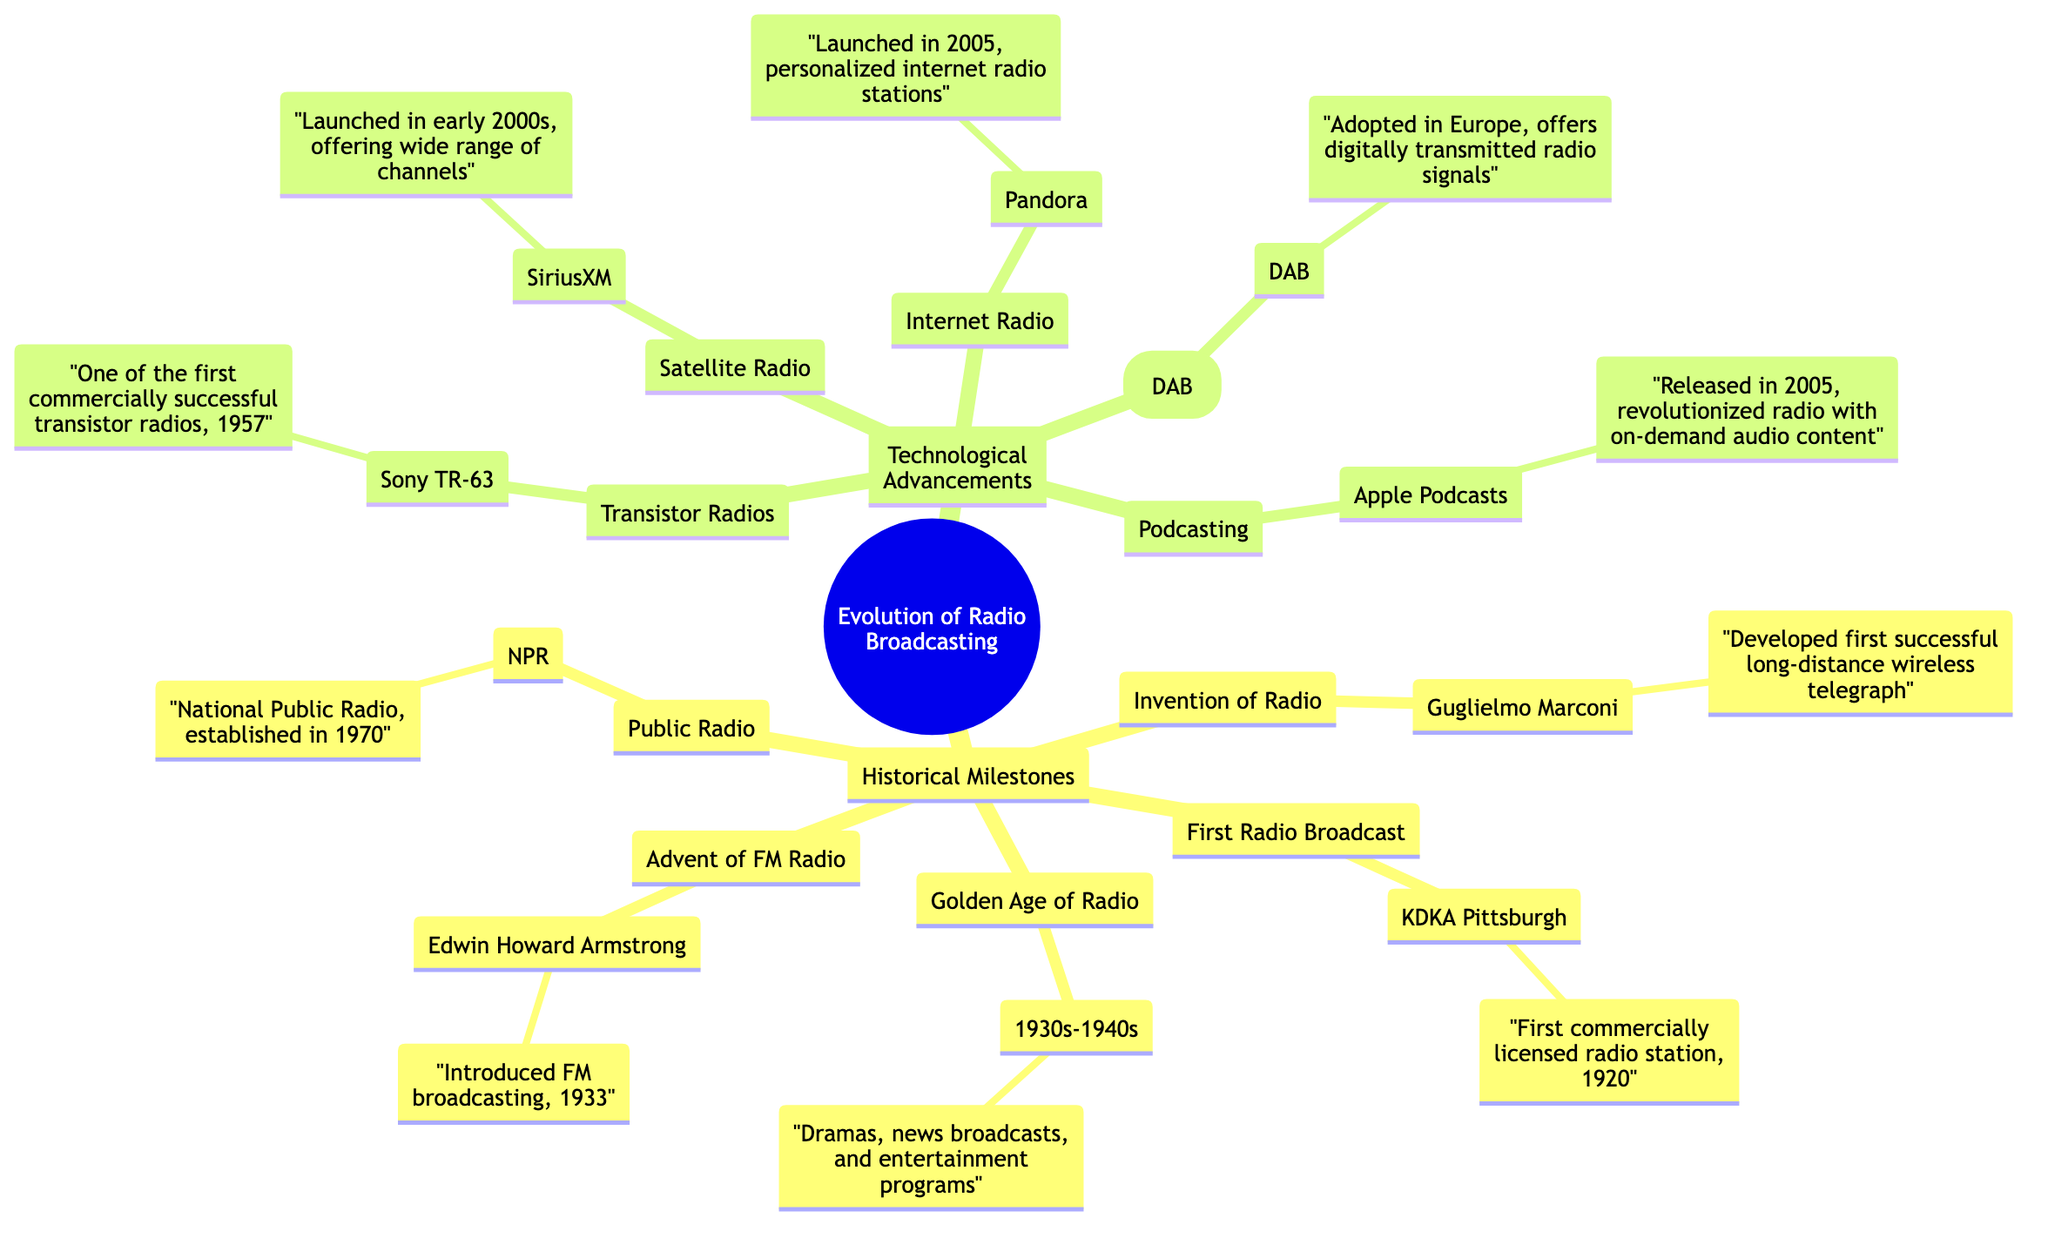What year was the first radio broadcast? The diagram specifies that KDKA Pittsburgh was the first commercially licensed radio station and it indicates the year 1920.
Answer: 1920 Who developed the first successful long-distance wireless telegraph? Guglielmo Marconi is credited as the inventor associated with the development of the first successful long-distance wireless telegraph in the diagram.
Answer: Guglielmo Marconi What major advancement in radio occurred in 1933? The diagram identifies Edwin Howard Armstrong as the person responsible for introducing FM broadcasting in the year 1933.
Answer: FM broadcasting How did NPR contribute to radio history? According to the diagram, NPR or National Public Radio was established in 1970, highlighting its significance in the development of public radio.
Answer: National Public Radio Which technology was launched in the early 2000s? The diagram notes that SiriusXM, which offers a wide range of channels, was launched in the early 2000s as a form of satellite radio.
Answer: SiriusXM How many historical milestones are listed in the diagram? By counting the categories listed under Historical Milestones in the diagram, we find there are five: Invention of Radio, First Radio Broadcast, Golden Age of Radio, Advent of FM Radio, and Public Radio.
Answer: 5 What is unique about Apple Podcasts in the context of radio broadcasting? The diagram refers to Apple Podcasts as having been released in 2005 and states it revolutionized radio by enabling on-demand audio content, indicating its distinct impact.
Answer: On-demand audio content Which radio innovation was introduced first, transistor radios or internet radio? The order of innovation in the diagram indicates that transistor radios, represented by the Sony TR-63 in 1957, came before internet radio, which was launched with Pandora in 2005.
Answer: Transistor radios How is Digital Audio Broadcasting described in the diagram? The diagram states that DAB, or Digital Audio Broadcasting, was adopted in Europe, which further characterizes it as a method for transmitting radio signals digitally.
Answer: Digitally transmitted radio signals 